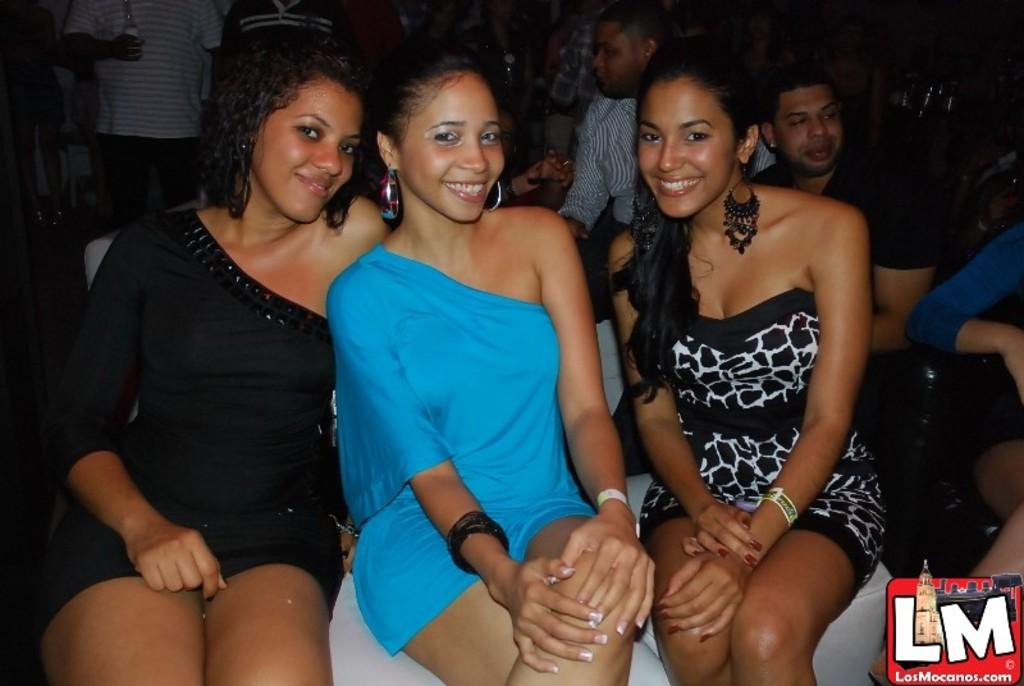What are the people in the image doing? There is a group of people sitting and people standing in the image. Can you describe the actions of one of the individuals in the image? There is a person holding a bottle in the image. What is the desire of the geese in the image? There are no geese present in the image, so it is not possible to determine their desires. Can you describe the beetle's role in the image? There is no beetle present in the image, so it is not possible to describe its role. 